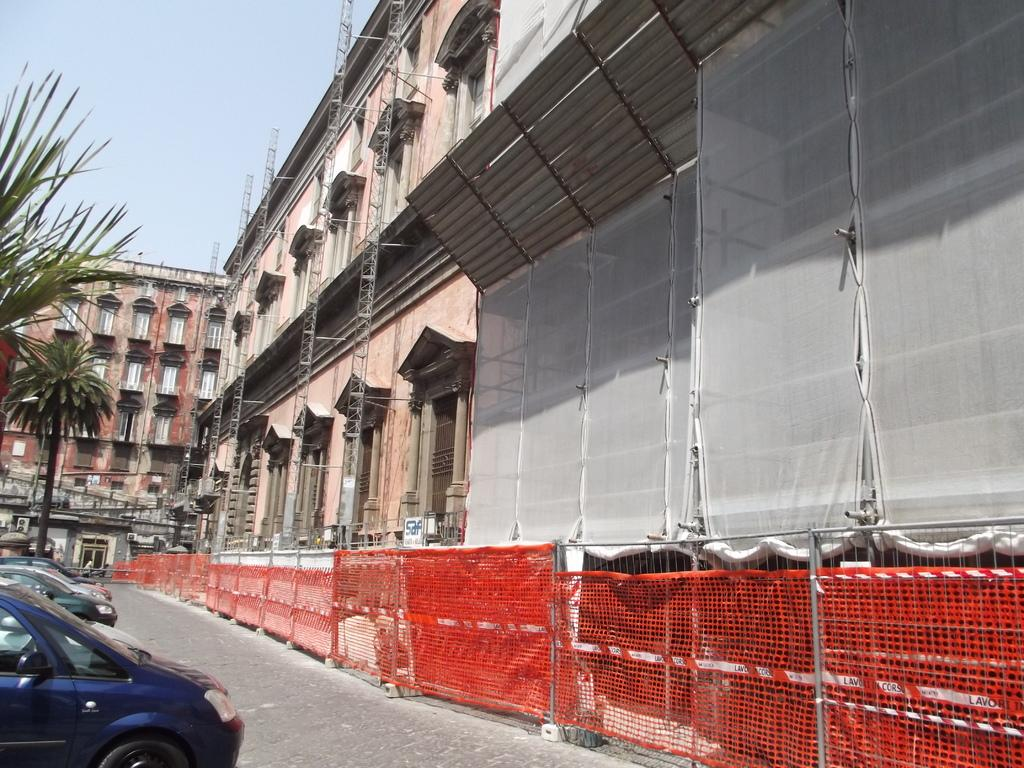What type of structure can be seen in the image? There is a building in the image. What is visible on the road near the building? There are cars on the road in the image. What type of vegetation is present in the image? There are trees in the image. What type of barrier is near the building? There is fencing near the building in the image. What is the price of the expert in the image? There is no expert or price mentioned in the image; it features a building, cars, trees, and fencing. 